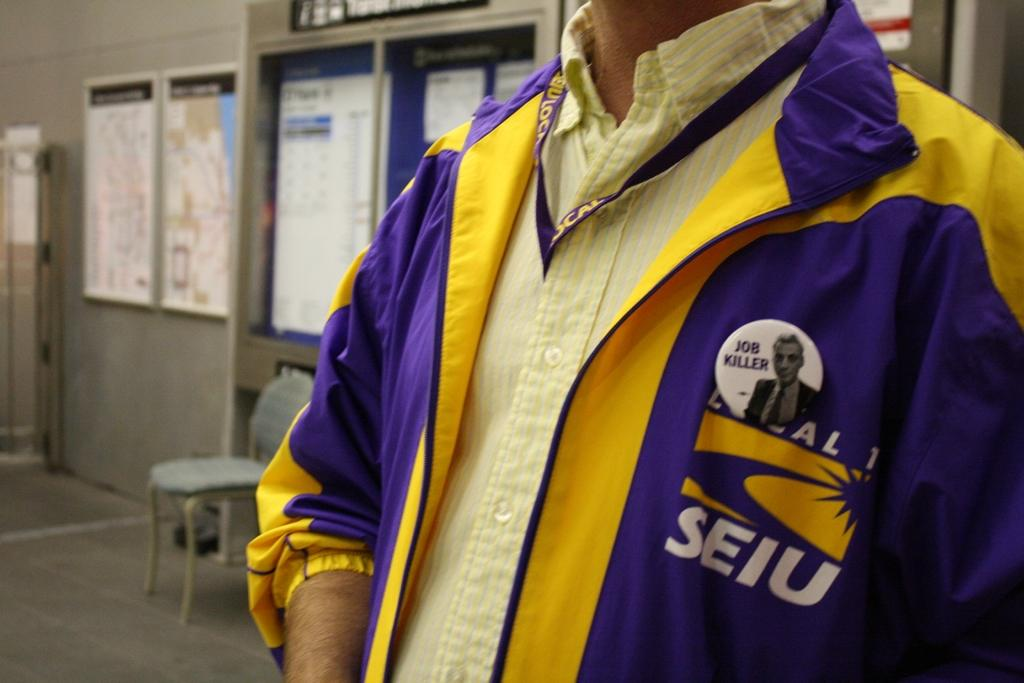<image>
Create a compact narrative representing the image presented. A man wearing a purple and yellow jacket with the logo SEIU 